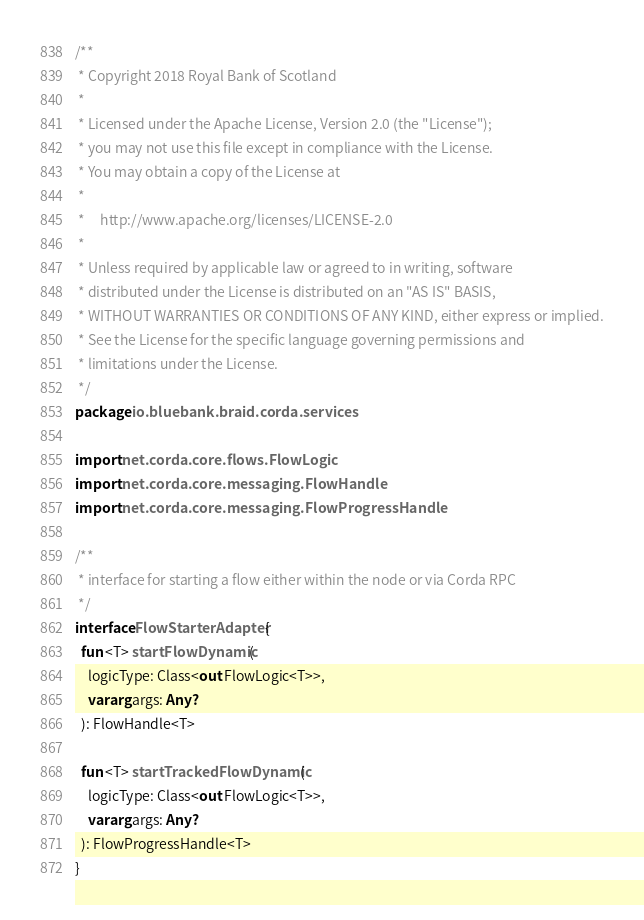<code> <loc_0><loc_0><loc_500><loc_500><_Kotlin_>/**
 * Copyright 2018 Royal Bank of Scotland
 *
 * Licensed under the Apache License, Version 2.0 (the "License");
 * you may not use this file except in compliance with the License.
 * You may obtain a copy of the License at
 *
 *     http://www.apache.org/licenses/LICENSE-2.0
 *
 * Unless required by applicable law or agreed to in writing, software
 * distributed under the License is distributed on an "AS IS" BASIS,
 * WITHOUT WARRANTIES OR CONDITIONS OF ANY KIND, either express or implied.
 * See the License for the specific language governing permissions and
 * limitations under the License.
 */
package io.bluebank.braid.corda.services

import net.corda.core.flows.FlowLogic
import net.corda.core.messaging.FlowHandle
import net.corda.core.messaging.FlowProgressHandle

/**
 * interface for starting a flow either within the node or via Corda RPC
 */
interface FlowStarterAdapter {
  fun <T> startFlowDynamic(
    logicType: Class<out FlowLogic<T>>,
    vararg args: Any?
  ): FlowHandle<T>

  fun <T> startTrackedFlowDynamic(
    logicType: Class<out FlowLogic<T>>,
    vararg args: Any?
  ): FlowProgressHandle<T>
}
</code> 